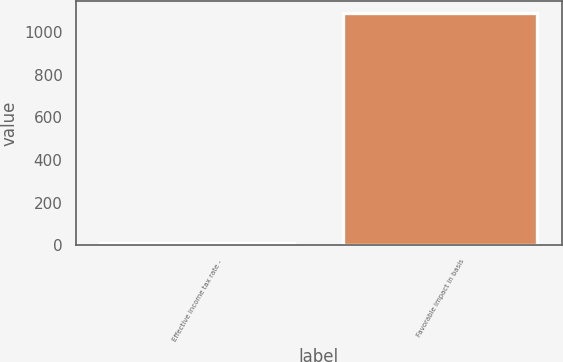Convert chart. <chart><loc_0><loc_0><loc_500><loc_500><bar_chart><fcel>Effective income tax rate -<fcel>Favorable impact in basis<nl><fcel>9.1<fcel>1090<nl></chart> 